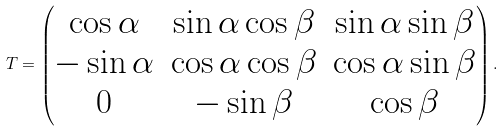<formula> <loc_0><loc_0><loc_500><loc_500>T = \begin{pmatrix} \cos \alpha & \sin \alpha \cos \beta & \sin \alpha \sin \beta \\ - \sin \alpha & \cos \alpha \cos \beta & \cos \alpha \sin \beta \\ 0 & - \sin \beta & \cos \beta \end{pmatrix} .</formula> 